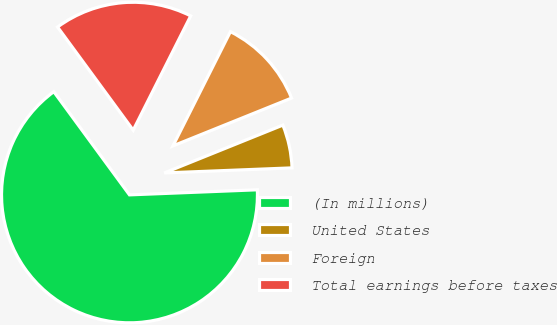Convert chart to OTSL. <chart><loc_0><loc_0><loc_500><loc_500><pie_chart><fcel>(In millions)<fcel>United States<fcel>Foreign<fcel>Total earnings before taxes<nl><fcel>65.56%<fcel>5.47%<fcel>11.48%<fcel>17.49%<nl></chart> 